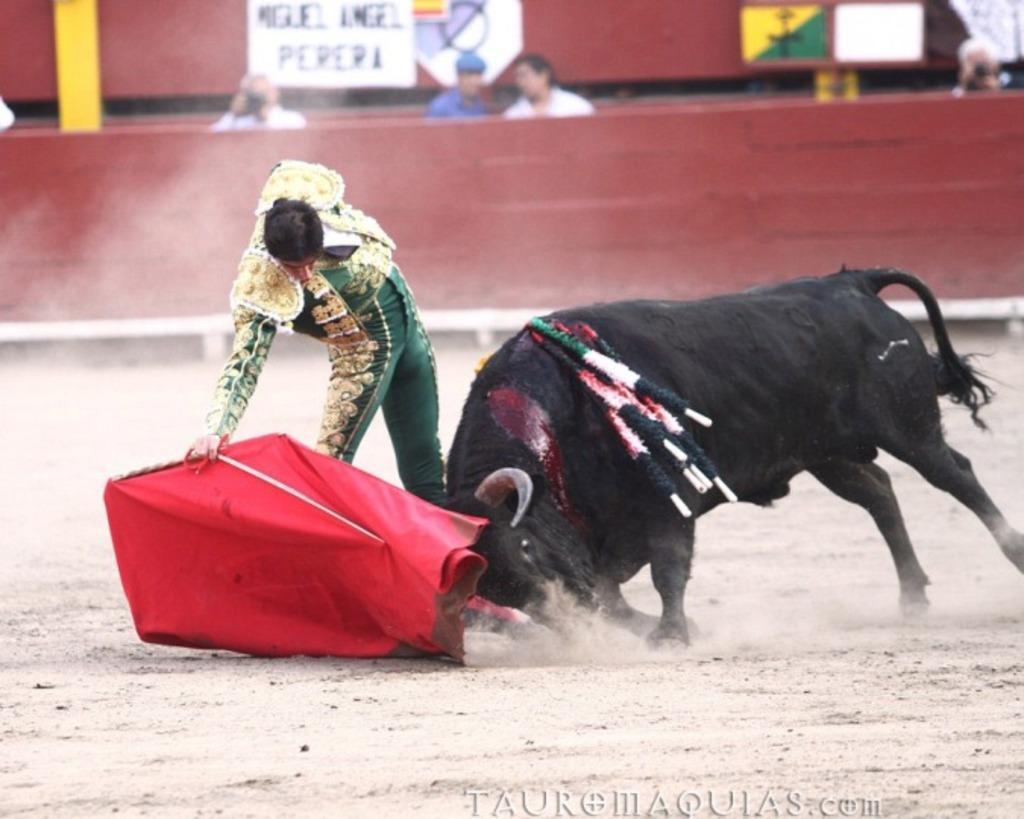How would you summarize this image in a sentence or two? In this image there is a person standing on the land. He is holding a red colored cloth. Right side there is a bull on the land. There are people behind the fence. There are boards attached to the wall. There is a person holding a camera. 